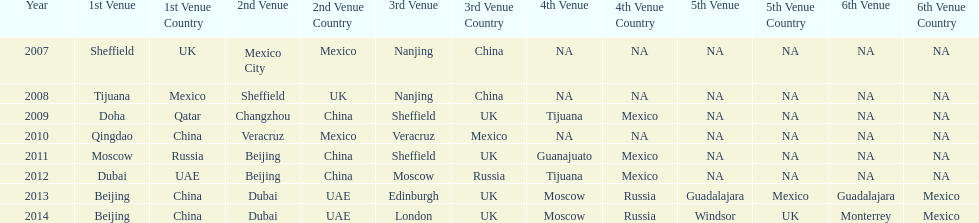What years had the most venues? 2013, 2014. 